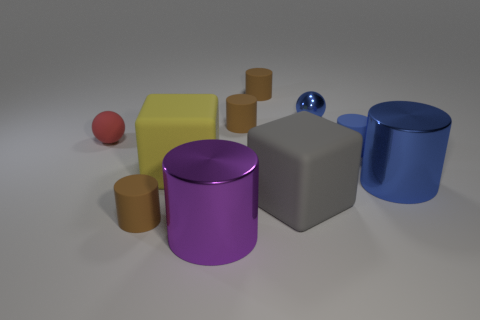What is the shape of the small blue thing that is in front of the blue object that is on the left side of the small blue matte object?
Provide a succinct answer. Cylinder. How many objects are tiny red shiny cubes or rubber cubes right of the purple thing?
Provide a succinct answer. 1. What is the color of the block that is left of the big thing that is in front of the tiny brown matte cylinder that is in front of the big gray rubber block?
Offer a terse response. Yellow. There is another tiny thing that is the same shape as the red matte thing; what is its material?
Your response must be concise. Metal. What color is the tiny rubber ball?
Offer a very short reply. Red. What number of rubber things are either tiny cylinders or tiny blue balls?
Your answer should be very brief. 4. Is there a small brown object that is behind the sphere that is to the left of the small brown object in front of the blue metal cylinder?
Provide a succinct answer. Yes. The gray cube that is the same material as the tiny red ball is what size?
Provide a succinct answer. Large. There is a large purple thing; are there any small metallic things right of it?
Offer a very short reply. Yes. Are there any tiny blue things behind the small rubber object on the right side of the tiny shiny ball?
Make the answer very short. Yes. 